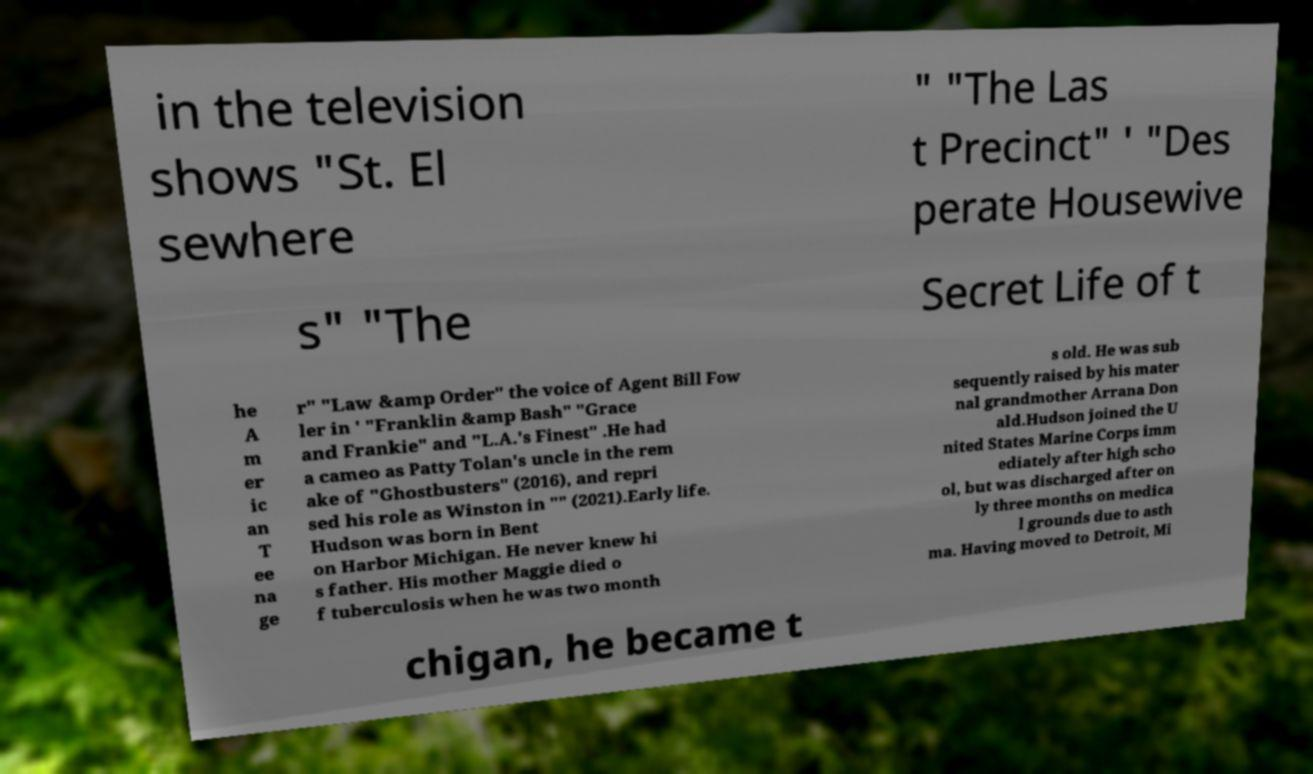Can you read and provide the text displayed in the image?This photo seems to have some interesting text. Can you extract and type it out for me? in the television shows "St. El sewhere " "The Las t Precinct" ' "Des perate Housewive s" "The Secret Life of t he A m er ic an T ee na ge r" "Law &amp Order" the voice of Agent Bill Fow ler in ' "Franklin &amp Bash" "Grace and Frankie" and "L.A.'s Finest" .He had a cameo as Patty Tolan's uncle in the rem ake of "Ghostbusters" (2016), and repri sed his role as Winston in "" (2021).Early life. Hudson was born in Bent on Harbor Michigan. He never knew hi s father. His mother Maggie died o f tuberculosis when he was two month s old. He was sub sequently raised by his mater nal grandmother Arrana Don ald.Hudson joined the U nited States Marine Corps imm ediately after high scho ol, but was discharged after on ly three months on medica l grounds due to asth ma. Having moved to Detroit, Mi chigan, he became t 